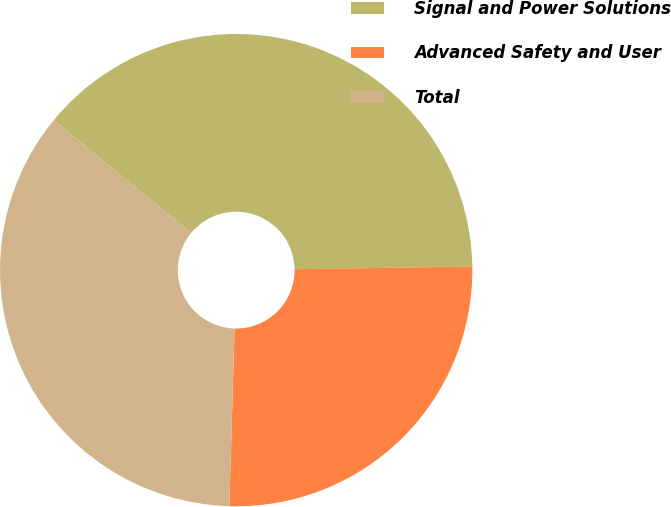Convert chart. <chart><loc_0><loc_0><loc_500><loc_500><pie_chart><fcel>Signal and Power Solutions<fcel>Advanced Safety and User<fcel>Total<nl><fcel>38.81%<fcel>25.7%<fcel>35.49%<nl></chart> 